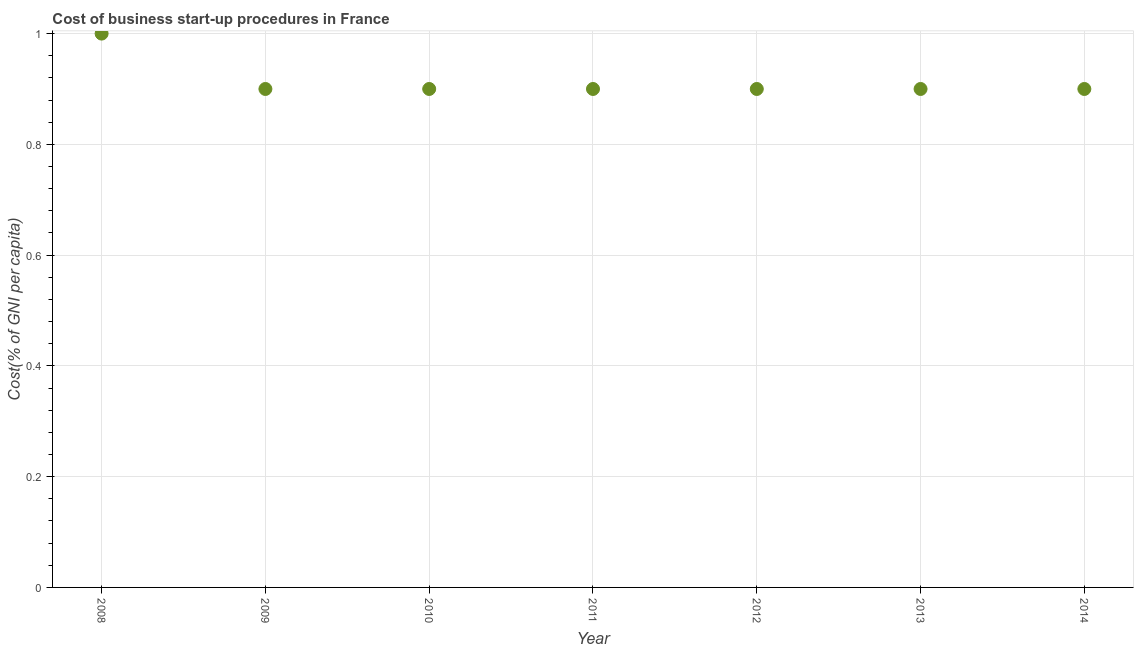Across all years, what is the minimum cost of business startup procedures?
Offer a terse response. 0.9. In which year was the cost of business startup procedures maximum?
Your response must be concise. 2008. In which year was the cost of business startup procedures minimum?
Provide a short and direct response. 2009. What is the sum of the cost of business startup procedures?
Provide a succinct answer. 6.4. What is the average cost of business startup procedures per year?
Provide a succinct answer. 0.91. Do a majority of the years between 2012 and 2014 (inclusive) have cost of business startup procedures greater than 0.6000000000000001 %?
Give a very brief answer. Yes. Is the cost of business startup procedures in 2009 less than that in 2013?
Give a very brief answer. No. What is the difference between the highest and the second highest cost of business startup procedures?
Your response must be concise. 0.1. Is the sum of the cost of business startup procedures in 2008 and 2009 greater than the maximum cost of business startup procedures across all years?
Make the answer very short. Yes. What is the difference between the highest and the lowest cost of business startup procedures?
Ensure brevity in your answer.  0.1. How many years are there in the graph?
Make the answer very short. 7. Does the graph contain grids?
Offer a terse response. Yes. What is the title of the graph?
Offer a very short reply. Cost of business start-up procedures in France. What is the label or title of the Y-axis?
Offer a very short reply. Cost(% of GNI per capita). What is the Cost(% of GNI per capita) in 2008?
Your answer should be compact. 1. What is the Cost(% of GNI per capita) in 2010?
Provide a short and direct response. 0.9. What is the Cost(% of GNI per capita) in 2012?
Provide a short and direct response. 0.9. What is the Cost(% of GNI per capita) in 2013?
Provide a short and direct response. 0.9. What is the difference between the Cost(% of GNI per capita) in 2008 and 2009?
Ensure brevity in your answer.  0.1. What is the difference between the Cost(% of GNI per capita) in 2008 and 2010?
Ensure brevity in your answer.  0.1. What is the difference between the Cost(% of GNI per capita) in 2008 and 2011?
Provide a succinct answer. 0.1. What is the difference between the Cost(% of GNI per capita) in 2008 and 2013?
Provide a short and direct response. 0.1. What is the difference between the Cost(% of GNI per capita) in 2009 and 2012?
Offer a terse response. 0. What is the difference between the Cost(% of GNI per capita) in 2009 and 2013?
Offer a very short reply. 0. What is the difference between the Cost(% of GNI per capita) in 2010 and 2011?
Provide a short and direct response. 0. What is the difference between the Cost(% of GNI per capita) in 2010 and 2012?
Provide a short and direct response. 0. What is the difference between the Cost(% of GNI per capita) in 2010 and 2013?
Make the answer very short. 0. What is the difference between the Cost(% of GNI per capita) in 2011 and 2012?
Provide a succinct answer. 0. What is the difference between the Cost(% of GNI per capita) in 2011 and 2013?
Your answer should be very brief. 0. What is the difference between the Cost(% of GNI per capita) in 2011 and 2014?
Give a very brief answer. 0. What is the difference between the Cost(% of GNI per capita) in 2012 and 2013?
Make the answer very short. 0. What is the ratio of the Cost(% of GNI per capita) in 2008 to that in 2009?
Your response must be concise. 1.11. What is the ratio of the Cost(% of GNI per capita) in 2008 to that in 2010?
Your answer should be compact. 1.11. What is the ratio of the Cost(% of GNI per capita) in 2008 to that in 2011?
Make the answer very short. 1.11. What is the ratio of the Cost(% of GNI per capita) in 2008 to that in 2012?
Offer a very short reply. 1.11. What is the ratio of the Cost(% of GNI per capita) in 2008 to that in 2013?
Your answer should be very brief. 1.11. What is the ratio of the Cost(% of GNI per capita) in 2008 to that in 2014?
Make the answer very short. 1.11. What is the ratio of the Cost(% of GNI per capita) in 2009 to that in 2010?
Make the answer very short. 1. What is the ratio of the Cost(% of GNI per capita) in 2009 to that in 2011?
Provide a short and direct response. 1. What is the ratio of the Cost(% of GNI per capita) in 2009 to that in 2014?
Offer a very short reply. 1. What is the ratio of the Cost(% of GNI per capita) in 2010 to that in 2012?
Your answer should be very brief. 1. What is the ratio of the Cost(% of GNI per capita) in 2010 to that in 2013?
Offer a terse response. 1. What is the ratio of the Cost(% of GNI per capita) in 2011 to that in 2012?
Your answer should be compact. 1. What is the ratio of the Cost(% of GNI per capita) in 2011 to that in 2014?
Give a very brief answer. 1. What is the ratio of the Cost(% of GNI per capita) in 2012 to that in 2014?
Provide a short and direct response. 1. What is the ratio of the Cost(% of GNI per capita) in 2013 to that in 2014?
Ensure brevity in your answer.  1. 